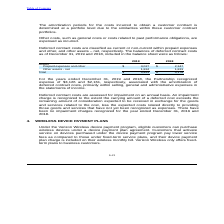According to Consolidated Communications Holdings's financial document, What was the expense recognized by the Partnership in 2019?  According to the financial document, $3,126. The relevant text states: "19 and 2018, the Partnership recognized expense of $3,126 and $2,161, respectively, associated with the amortization of deferred contract costs, primarily wit..." Also, What is the Total assets for 2019? According to the financial document, $ 4,851. The relevant text states: "Total $ 4,851 $ 4,178..." Also, What are the impairment charges in 2019? There have been no impairment charges recognized for the year ended December 31, 2019. The document states: "es that have not yet been recognized as expenses. There have been no impairment charges recognized for the year ended December 31, 2019 and 2018...." Also, can you calculate: What was the increase / (decrease) in the prepaid expenses and other assets from 2018 to 2019? Based on the calculation: 3,027 - 2,347, the result is 680. This is based on the information: "Prepaid expenses and other $ 3,027 $ 2,347 Prepaid expenses and other $ 3,027 $ 2,347..." The key data points involved are: 2,347, 3,027. Also, can you calculate: What was the average other assets-net for 2018 and 2019? To answer this question, I need to perform calculations using the financial data. The calculation is: (1,824 + 1,831) / 2, which equals 1827.5. This is based on the information: "Other assets - net 1,824 1,831 Other assets - net 1,824 1,831..." The key data points involved are: 1,824, 1,831. Also, can you calculate: What was the percentage increase / (decrease) in the total assets from 2018 to 2019? To answer this question, I need to perform calculations using the financial data. The calculation is: 4,851 / 4,178 - 1, which equals 16.11 (percentage). This is based on the information: "Total $ 4,851 $ 4,178 Total $ 4,851 $ 4,178..." The key data points involved are: 4,178, 4,851. 